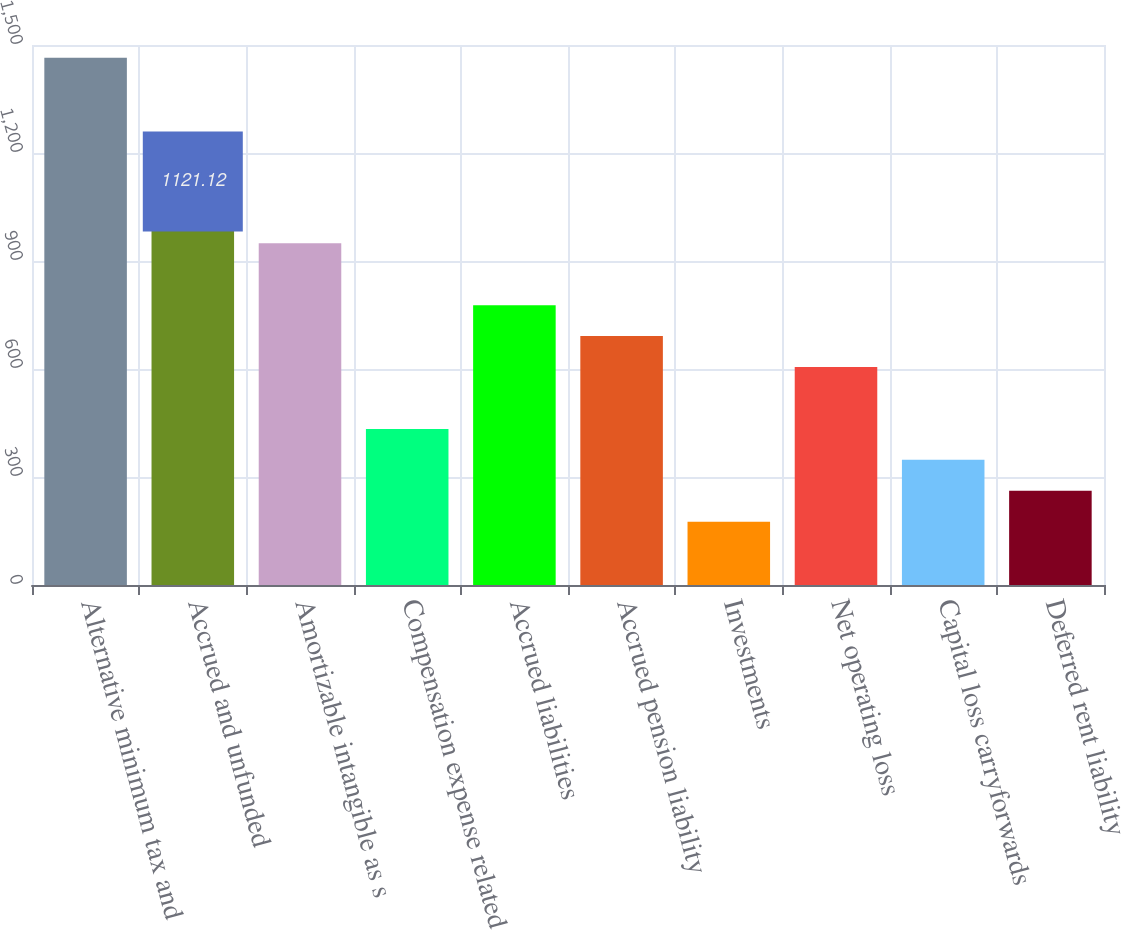Convert chart. <chart><loc_0><loc_0><loc_500><loc_500><bar_chart><fcel>Alternative minimum tax and<fcel>Accrued and unfunded<fcel>Amortizable intangible as s<fcel>Compensation expense related<fcel>Accrued liabilities<fcel>Accrued pension liability<fcel>Investments<fcel>Net operating loss<fcel>Capital loss carryforwards<fcel>Deferred rent liability<nl><fcel>1464.88<fcel>1121.12<fcel>949.24<fcel>433.6<fcel>777.36<fcel>691.42<fcel>175.78<fcel>605.48<fcel>347.66<fcel>261.72<nl></chart> 